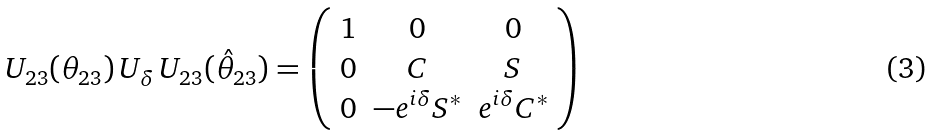Convert formula to latex. <formula><loc_0><loc_0><loc_500><loc_500>U _ { 2 3 } ( \theta _ { 2 3 } ) \, U _ { \delta } \, U _ { 2 3 } ( \hat { \theta } _ { 2 3 } ) = \left ( \begin{array} { c c c } 1 & 0 & 0 \\ 0 & C & S \\ 0 & - e ^ { i \delta } S ^ { * } & e ^ { i \delta } C ^ { * } \end{array} \right )</formula> 